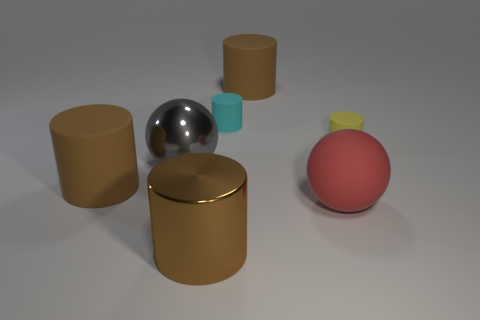What number of cylinders are both on the left side of the red rubber thing and behind the large metal ball?
Make the answer very short. 2. There is a large ball right of the big brown object that is right of the cyan thing that is behind the tiny yellow matte thing; what is its material?
Make the answer very short. Rubber. What number of small cyan cylinders have the same material as the yellow object?
Provide a succinct answer. 1. There is a red rubber object that is the same size as the brown metallic object; what shape is it?
Offer a terse response. Sphere. Are there any small cyan matte objects right of the large gray object?
Ensure brevity in your answer.  Yes. Is there a small yellow matte object of the same shape as the big red object?
Provide a succinct answer. No. There is a large metallic object that is on the right side of the large gray metal sphere; is it the same shape as the brown matte object that is left of the cyan rubber cylinder?
Make the answer very short. Yes. Is there a cyan cylinder of the same size as the cyan object?
Ensure brevity in your answer.  No. Is the number of large gray objects right of the red object the same as the number of big things that are to the left of the gray shiny thing?
Offer a very short reply. No. Is the large sphere that is behind the matte sphere made of the same material as the sphere right of the large gray metallic ball?
Your response must be concise. No. 